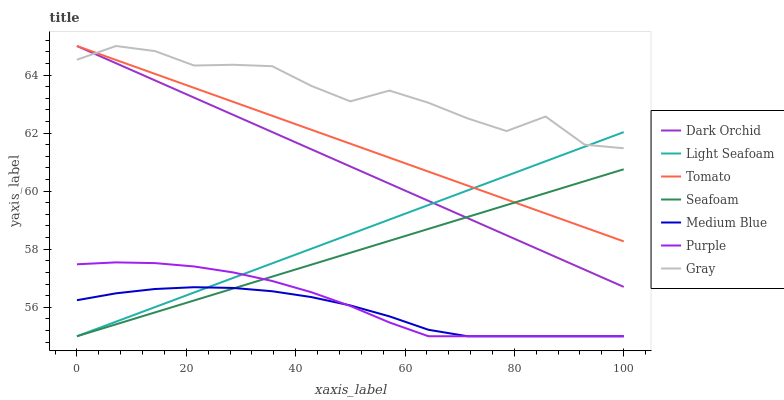Does Medium Blue have the minimum area under the curve?
Answer yes or no. Yes. Does Gray have the maximum area under the curve?
Answer yes or no. Yes. Does Purple have the minimum area under the curve?
Answer yes or no. No. Does Purple have the maximum area under the curve?
Answer yes or no. No. Is Dark Orchid the smoothest?
Answer yes or no. Yes. Is Gray the roughest?
Answer yes or no. Yes. Is Purple the smoothest?
Answer yes or no. No. Is Purple the roughest?
Answer yes or no. No. Does Purple have the lowest value?
Answer yes or no. Yes. Does Gray have the lowest value?
Answer yes or no. No. Does Dark Orchid have the highest value?
Answer yes or no. Yes. Does Purple have the highest value?
Answer yes or no. No. Is Seafoam less than Gray?
Answer yes or no. Yes. Is Dark Orchid greater than Medium Blue?
Answer yes or no. Yes. Does Medium Blue intersect Purple?
Answer yes or no. Yes. Is Medium Blue less than Purple?
Answer yes or no. No. Is Medium Blue greater than Purple?
Answer yes or no. No. Does Seafoam intersect Gray?
Answer yes or no. No. 